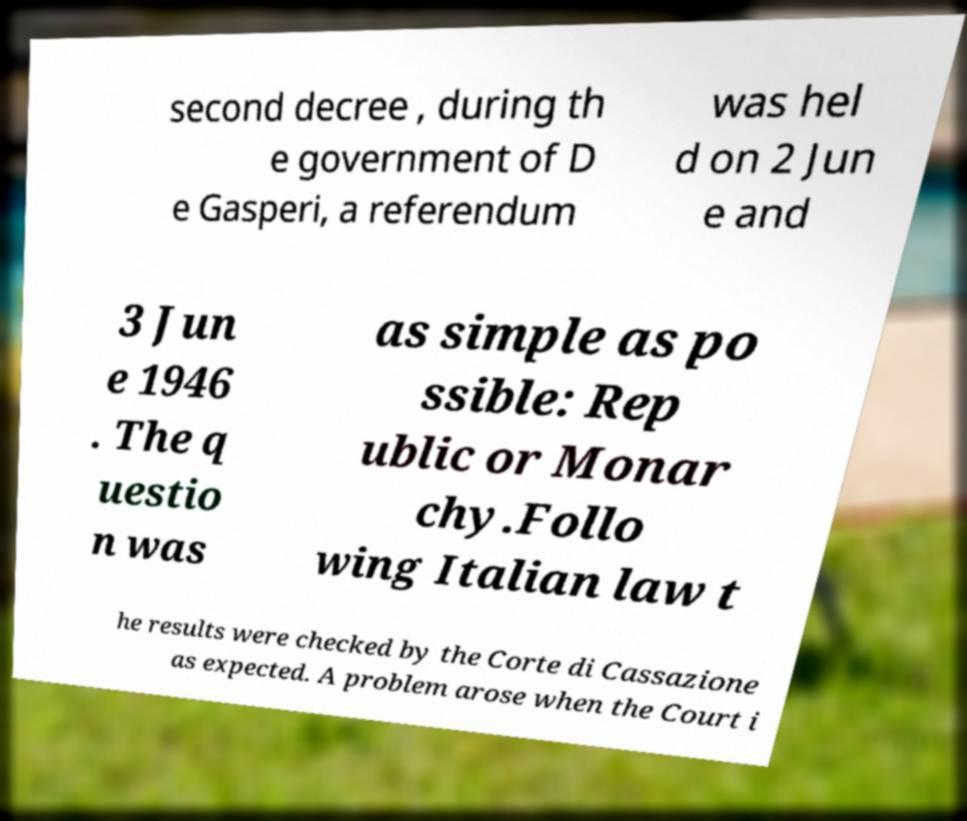What messages or text are displayed in this image? I need them in a readable, typed format. second decree , during th e government of D e Gasperi, a referendum was hel d on 2 Jun e and 3 Jun e 1946 . The q uestio n was as simple as po ssible: Rep ublic or Monar chy.Follo wing Italian law t he results were checked by the Corte di Cassazione as expected. A problem arose when the Court i 